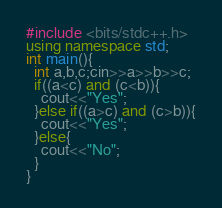<code> <loc_0><loc_0><loc_500><loc_500><_C++_>#include <bits/stdc++.h>
using namespace std;
int main(){
  int a,b,c;cin>>a>>b>>c;
  if((a<c) and (c<b)){
    cout<<"Yes";
  }else if((a>c) and (c>b)){
    cout<<"Yes";
  }else{
    cout<<"No";
  }
}</code> 